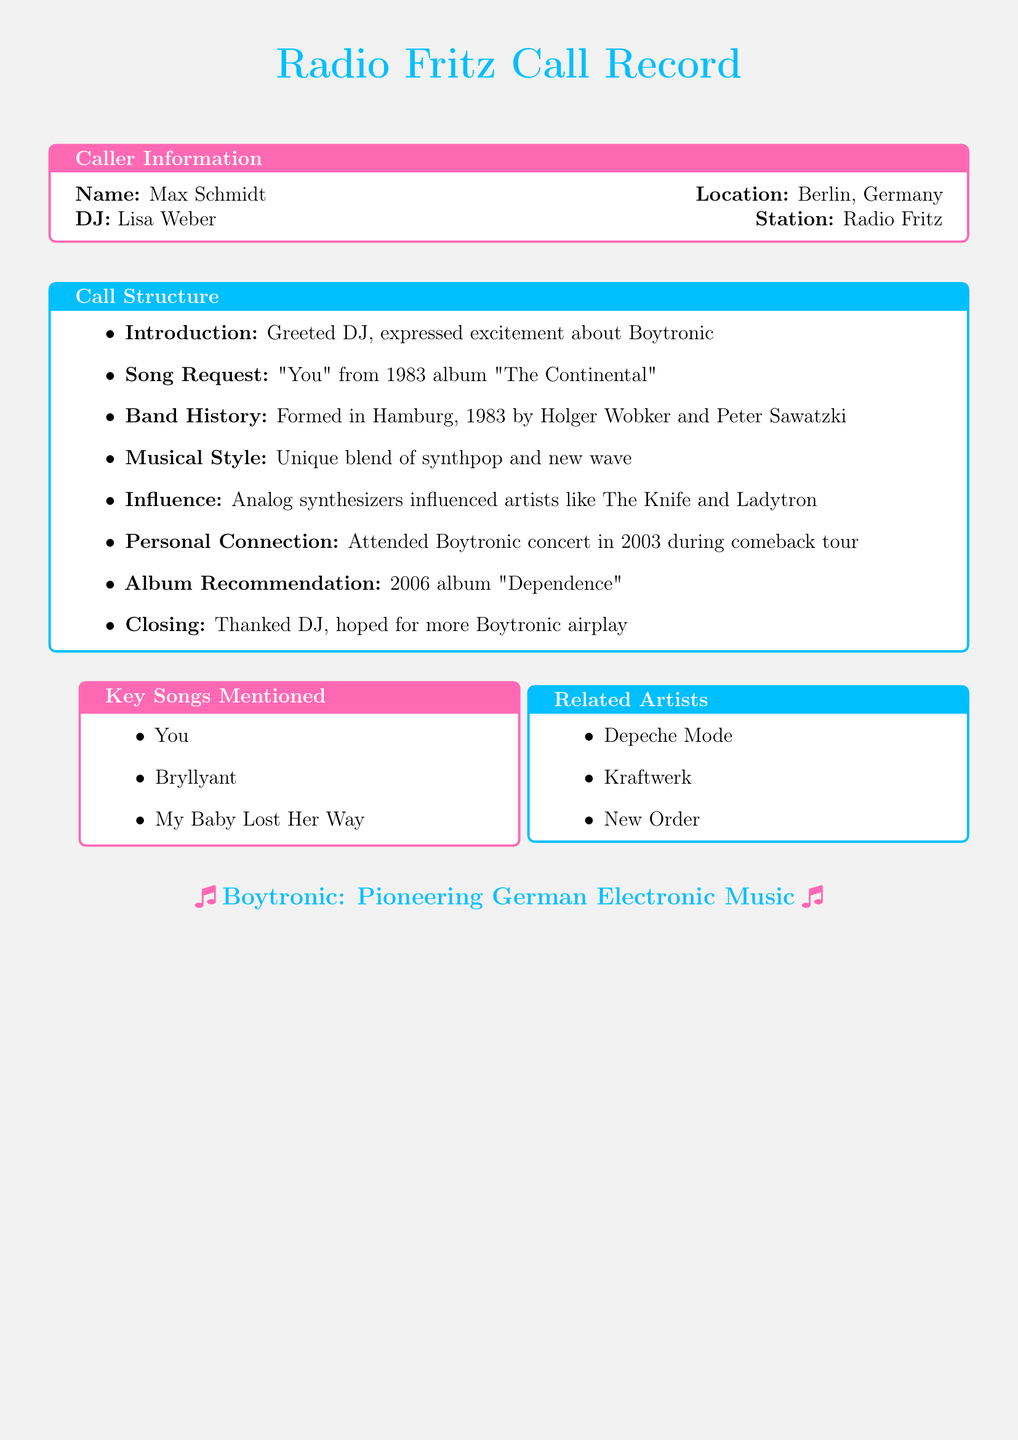What is the caller's name? The caller's name is the individual who initiated the call to the radio station.
Answer: Max Schmidt What song did the caller request? The document details a specific song requested by the caller during the conversation.
Answer: You In what year was Boytronic formed? The year refers to the founding year of the band mentioned in the document.
Answer: 1983 Which album contains the song "You"? The document indicates the album associated with the requested song.
Answer: The Continental What is the musical style of Boytronic? This question seeks to identify the genre that characterizes Boytronic's music as mentioned in the document.
Answer: Synthpop and new wave Which concert did the caller attend? The caller shares a personal experience related to Boytronic, indicated in the document.
Answer: Boytronic concert in 2003 Which artists were influenced by Boytronic? This question refers to the artists mentioned in the document who were noted to be influenced by Boytronic’s music style.
Answer: The Knife and Ladytron What album was recommended by the caller? The document includes a personal suggestion made by the caller during the conversation.
Answer: Dependence Who was the DJ at Radio Fritz? This question seeks to identify the DJ involved in the call as presented in the document.
Answer: Lisa Weber What city is the caller from? This question focuses on the location of the caller as stated in the document.
Answer: Berlin, Germany 